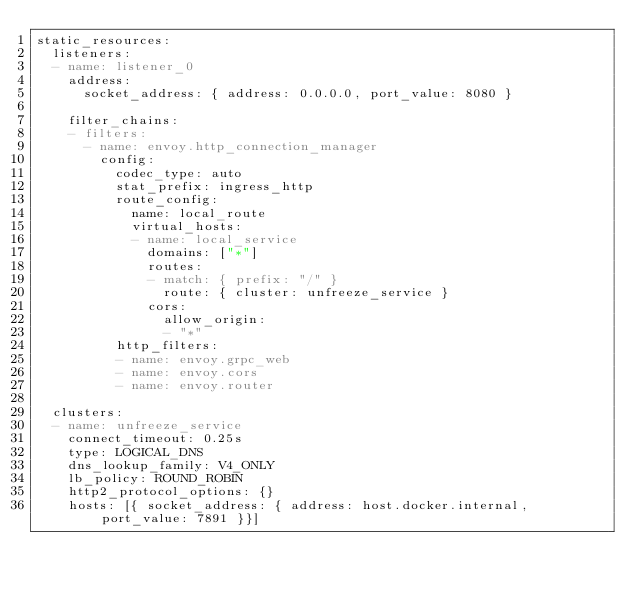<code> <loc_0><loc_0><loc_500><loc_500><_YAML_>static_resources:
  listeners:
  - name: listener_0
    address:
      socket_address: { address: 0.0.0.0, port_value: 8080 }

    filter_chains:
    - filters:
      - name: envoy.http_connection_manager
        config:
          codec_type: auto
          stat_prefix: ingress_http
          route_config:
            name: local_route
            virtual_hosts:
            - name: local_service
              domains: ["*"]
              routes:
              - match: { prefix: "/" }
                route: { cluster: unfreeze_service }
              cors:
                allow_origin:
                - "*"
          http_filters:
          - name: envoy.grpc_web
          - name: envoy.cors
          - name: envoy.router

  clusters:
  - name: unfreeze_service
    connect_timeout: 0.25s
    type: LOGICAL_DNS
    dns_lookup_family: V4_ONLY
    lb_policy: ROUND_ROBIN
    http2_protocol_options: {}
    hosts: [{ socket_address: { address: host.docker.internal, port_value: 7891 }}]
</code> 